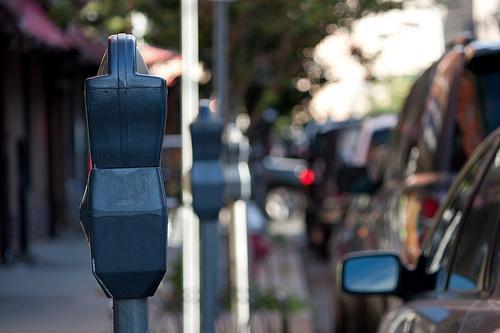How many meters are there?
Give a very brief answer. 2. 